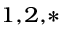<formula> <loc_0><loc_0><loc_500><loc_500>^ { 1 , 2 , * }</formula> 